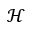Convert formula to latex. <formula><loc_0><loc_0><loc_500><loc_500>\mathcal { H }</formula> 